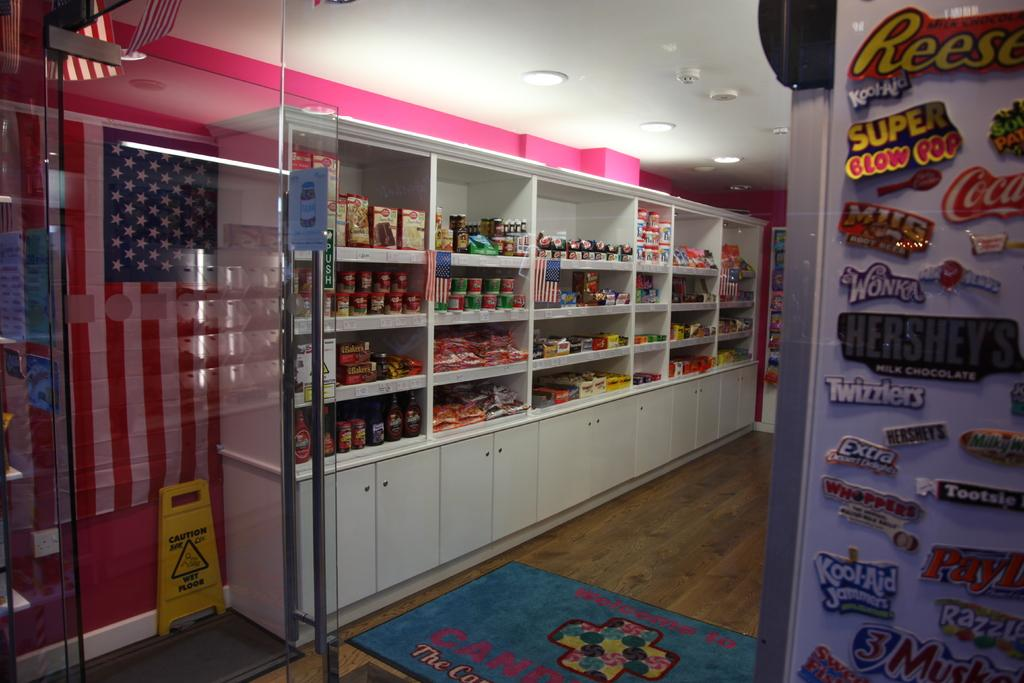Provide a one-sentence caption for the provided image. A shop has many magnets on one wall, including one for Super Blow Pops. 